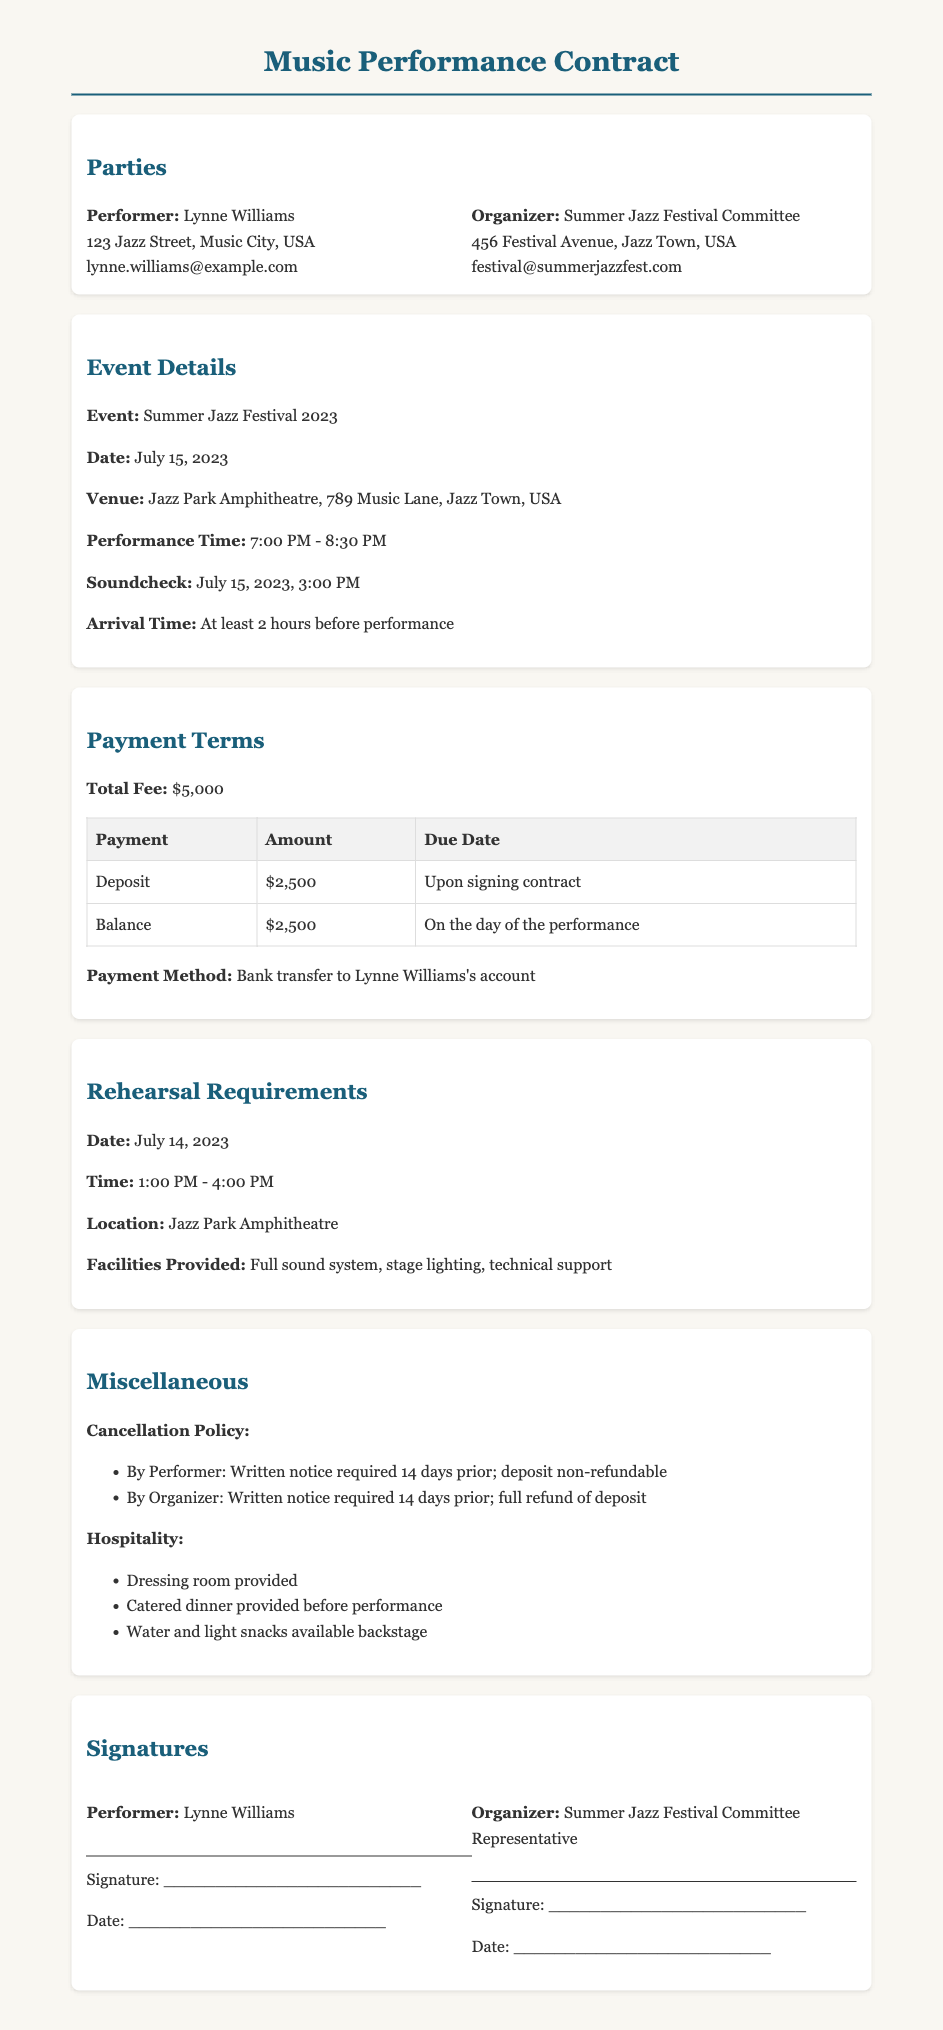what is the total fee for the performance? The total fee is stated in the Payment Terms section of the document.
Answer: $5,000 what is the date of the performance? The date of the event is indicated in the Event Details section.
Answer: July 15, 2023 what time does the performance start? The performance time is specified in the Event Details section of the document.
Answer: 7:00 PM what is the location for the rehearsal? The rehearsal location is detailed in the Rehearsal Requirements section.
Answer: Jazz Park Amphitheatre how long is the performance scheduled to last? The duration of the performance is indicated by the start and end times in the Event Details section.
Answer: 1 hour 30 minutes what is the payment method mentioned in the contract? The payment method is mentioned in the Payment Terms section of the document.
Answer: Bank transfer to Lynne Williams's account what is the arrival time requirement before the performance? The arrival time is specified in the Event Details section.
Answer: At least 2 hours before performance what must the performer provide for a cancellation? The cancellation policy outlines the requirement in case of a cancellation by the performer.
Answer: Written notice required 14 days prior what facilities will be provided during the rehearsal? The facilities for the rehearsal are listed in the Rehearsal Requirements section.
Answer: Full sound system, stage lighting, technical support 